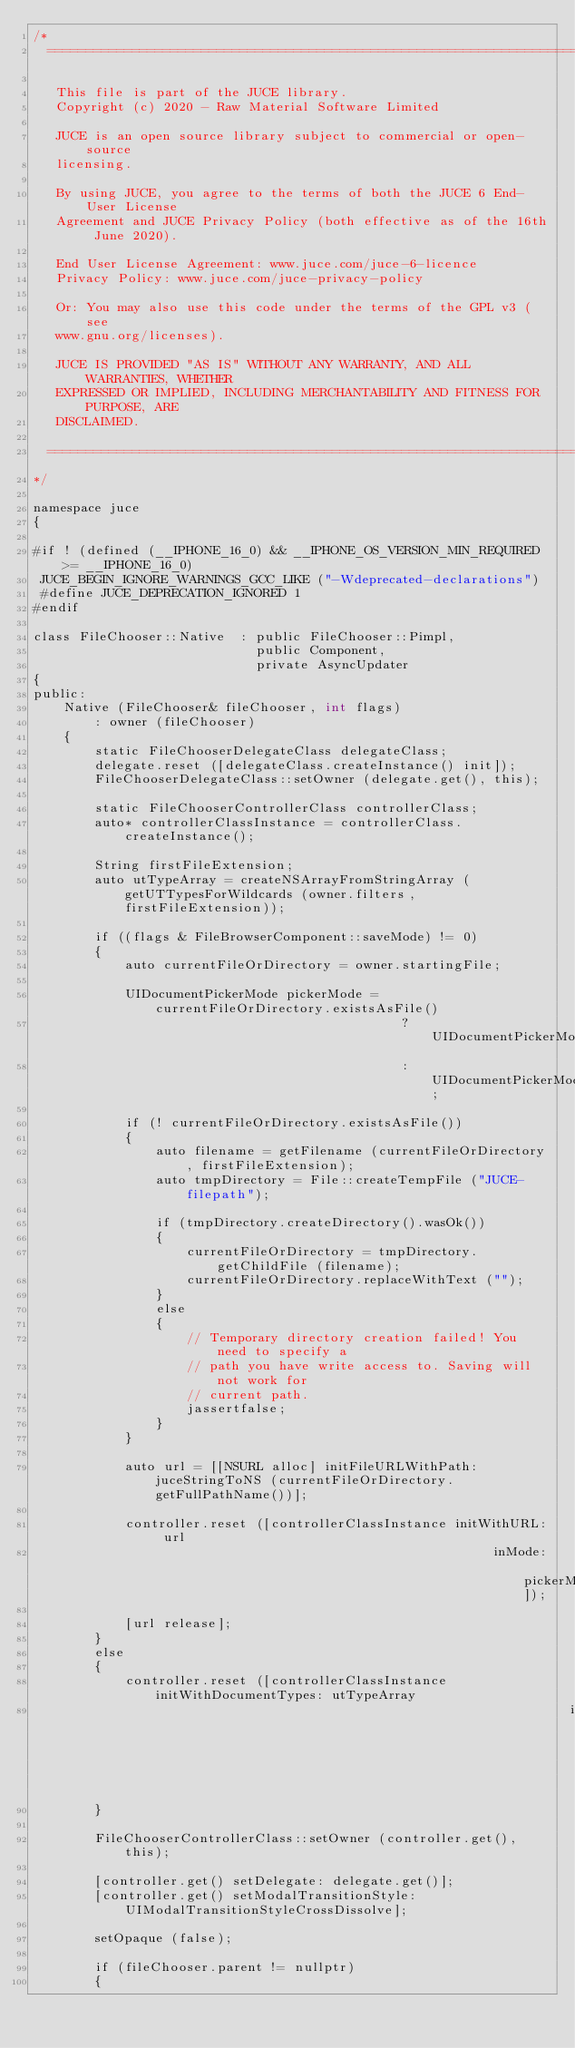<code> <loc_0><loc_0><loc_500><loc_500><_ObjectiveC_>/*
  ==============================================================================

   This file is part of the JUCE library.
   Copyright (c) 2020 - Raw Material Software Limited

   JUCE is an open source library subject to commercial or open-source
   licensing.

   By using JUCE, you agree to the terms of both the JUCE 6 End-User License
   Agreement and JUCE Privacy Policy (both effective as of the 16th June 2020).

   End User License Agreement: www.juce.com/juce-6-licence
   Privacy Policy: www.juce.com/juce-privacy-policy

   Or: You may also use this code under the terms of the GPL v3 (see
   www.gnu.org/licenses).

   JUCE IS PROVIDED "AS IS" WITHOUT ANY WARRANTY, AND ALL WARRANTIES, WHETHER
   EXPRESSED OR IMPLIED, INCLUDING MERCHANTABILITY AND FITNESS FOR PURPOSE, ARE
   DISCLAIMED.

  ==============================================================================
*/

namespace juce
{

#if ! (defined (__IPHONE_16_0) && __IPHONE_OS_VERSION_MIN_REQUIRED >= __IPHONE_16_0)
 JUCE_BEGIN_IGNORE_WARNINGS_GCC_LIKE ("-Wdeprecated-declarations")
 #define JUCE_DEPRECATION_IGNORED 1
#endif

class FileChooser::Native  : public FileChooser::Pimpl,
                             public Component,
                             private AsyncUpdater
{
public:
    Native (FileChooser& fileChooser, int flags)
        : owner (fileChooser)
    {
        static FileChooserDelegateClass delegateClass;
        delegate.reset ([delegateClass.createInstance() init]);
        FileChooserDelegateClass::setOwner (delegate.get(), this);

        static FileChooserControllerClass controllerClass;
        auto* controllerClassInstance = controllerClass.createInstance();

        String firstFileExtension;
        auto utTypeArray = createNSArrayFromStringArray (getUTTypesForWildcards (owner.filters, firstFileExtension));

        if ((flags & FileBrowserComponent::saveMode) != 0)
        {
            auto currentFileOrDirectory = owner.startingFile;

            UIDocumentPickerMode pickerMode = currentFileOrDirectory.existsAsFile()
                                                ? UIDocumentPickerModeExportToService
                                                : UIDocumentPickerModeMoveToService;

            if (! currentFileOrDirectory.existsAsFile())
            {
                auto filename = getFilename (currentFileOrDirectory, firstFileExtension);
                auto tmpDirectory = File::createTempFile ("JUCE-filepath");

                if (tmpDirectory.createDirectory().wasOk())
                {
                    currentFileOrDirectory = tmpDirectory.getChildFile (filename);
                    currentFileOrDirectory.replaceWithText ("");
                }
                else
                {
                    // Temporary directory creation failed! You need to specify a
                    // path you have write access to. Saving will not work for
                    // current path.
                    jassertfalse;
                }
            }

            auto url = [[NSURL alloc] initFileURLWithPath: juceStringToNS (currentFileOrDirectory.getFullPathName())];

            controller.reset ([controllerClassInstance initWithURL: url
                                                            inMode: pickerMode]);

            [url release];
        }
        else
        {
            controller.reset ([controllerClassInstance initWithDocumentTypes: utTypeArray
                                                                      inMode: UIDocumentPickerModeOpen]);
        }

        FileChooserControllerClass::setOwner (controller.get(), this);

        [controller.get() setDelegate: delegate.get()];
        [controller.get() setModalTransitionStyle: UIModalTransitionStyleCrossDissolve];

        setOpaque (false);

        if (fileChooser.parent != nullptr)
        {</code> 